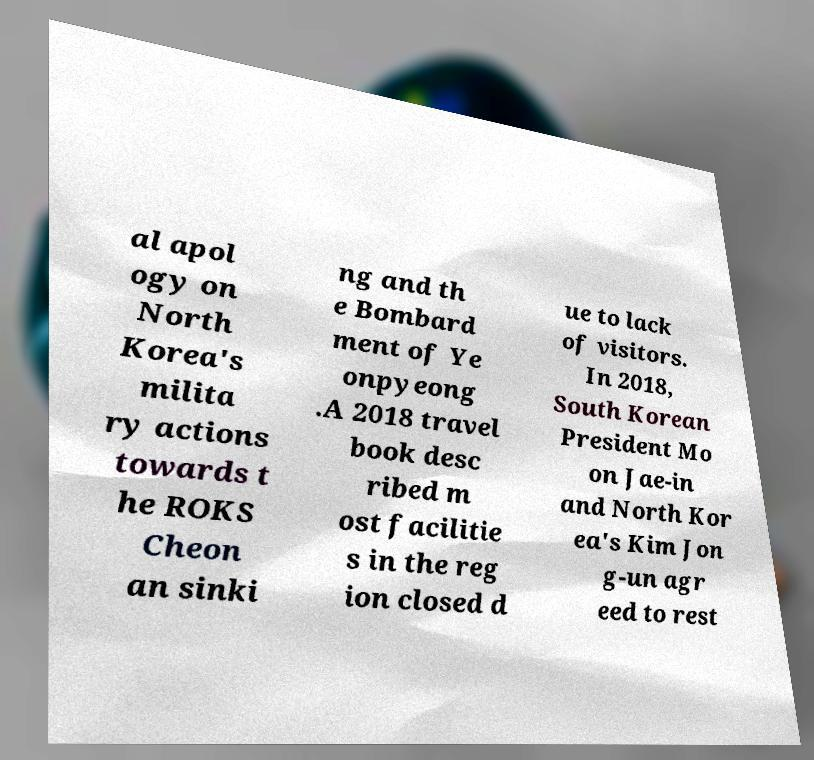There's text embedded in this image that I need extracted. Can you transcribe it verbatim? al apol ogy on North Korea's milita ry actions towards t he ROKS Cheon an sinki ng and th e Bombard ment of Ye onpyeong .A 2018 travel book desc ribed m ost facilitie s in the reg ion closed d ue to lack of visitors. In 2018, South Korean President Mo on Jae-in and North Kor ea's Kim Jon g-un agr eed to rest 